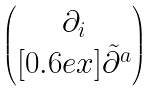Convert formula to latex. <formula><loc_0><loc_0><loc_500><loc_500>\begin{pmatrix} \, \partial _ { i } \, \\ [ 0 . 6 e x ] { \tilde { \partial } ^ { a } } \end{pmatrix}</formula> 